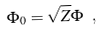Convert formula to latex. <formula><loc_0><loc_0><loc_500><loc_500>\Phi _ { 0 } = \sqrt { Z } \Phi \ ,</formula> 